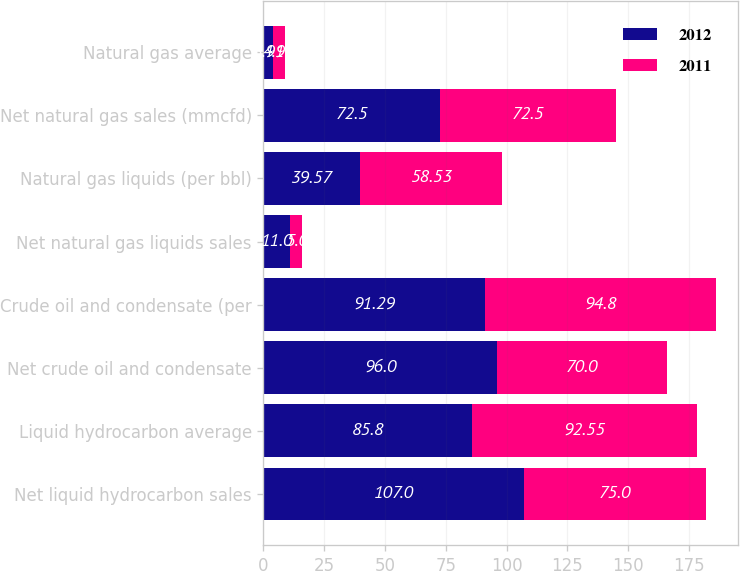Convert chart. <chart><loc_0><loc_0><loc_500><loc_500><stacked_bar_chart><ecel><fcel>Net liquid hydrocarbon sales<fcel>Liquid hydrocarbon average<fcel>Net crude oil and condensate<fcel>Crude oil and condensate (per<fcel>Net natural gas liquids sales<fcel>Natural gas liquids (per bbl)<fcel>Net natural gas sales (mmcfd)<fcel>Natural gas average<nl><fcel>2012<fcel>107<fcel>85.8<fcel>96<fcel>91.29<fcel>11<fcel>39.57<fcel>72.5<fcel>3.91<nl><fcel>2011<fcel>75<fcel>92.55<fcel>70<fcel>94.8<fcel>5<fcel>58.53<fcel>72.5<fcel>4.95<nl></chart> 